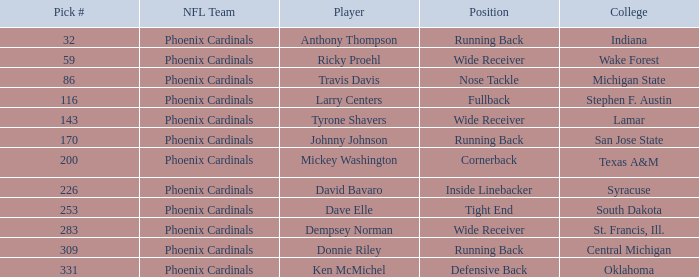Which college offers a nose tackle spot? Michigan State. 